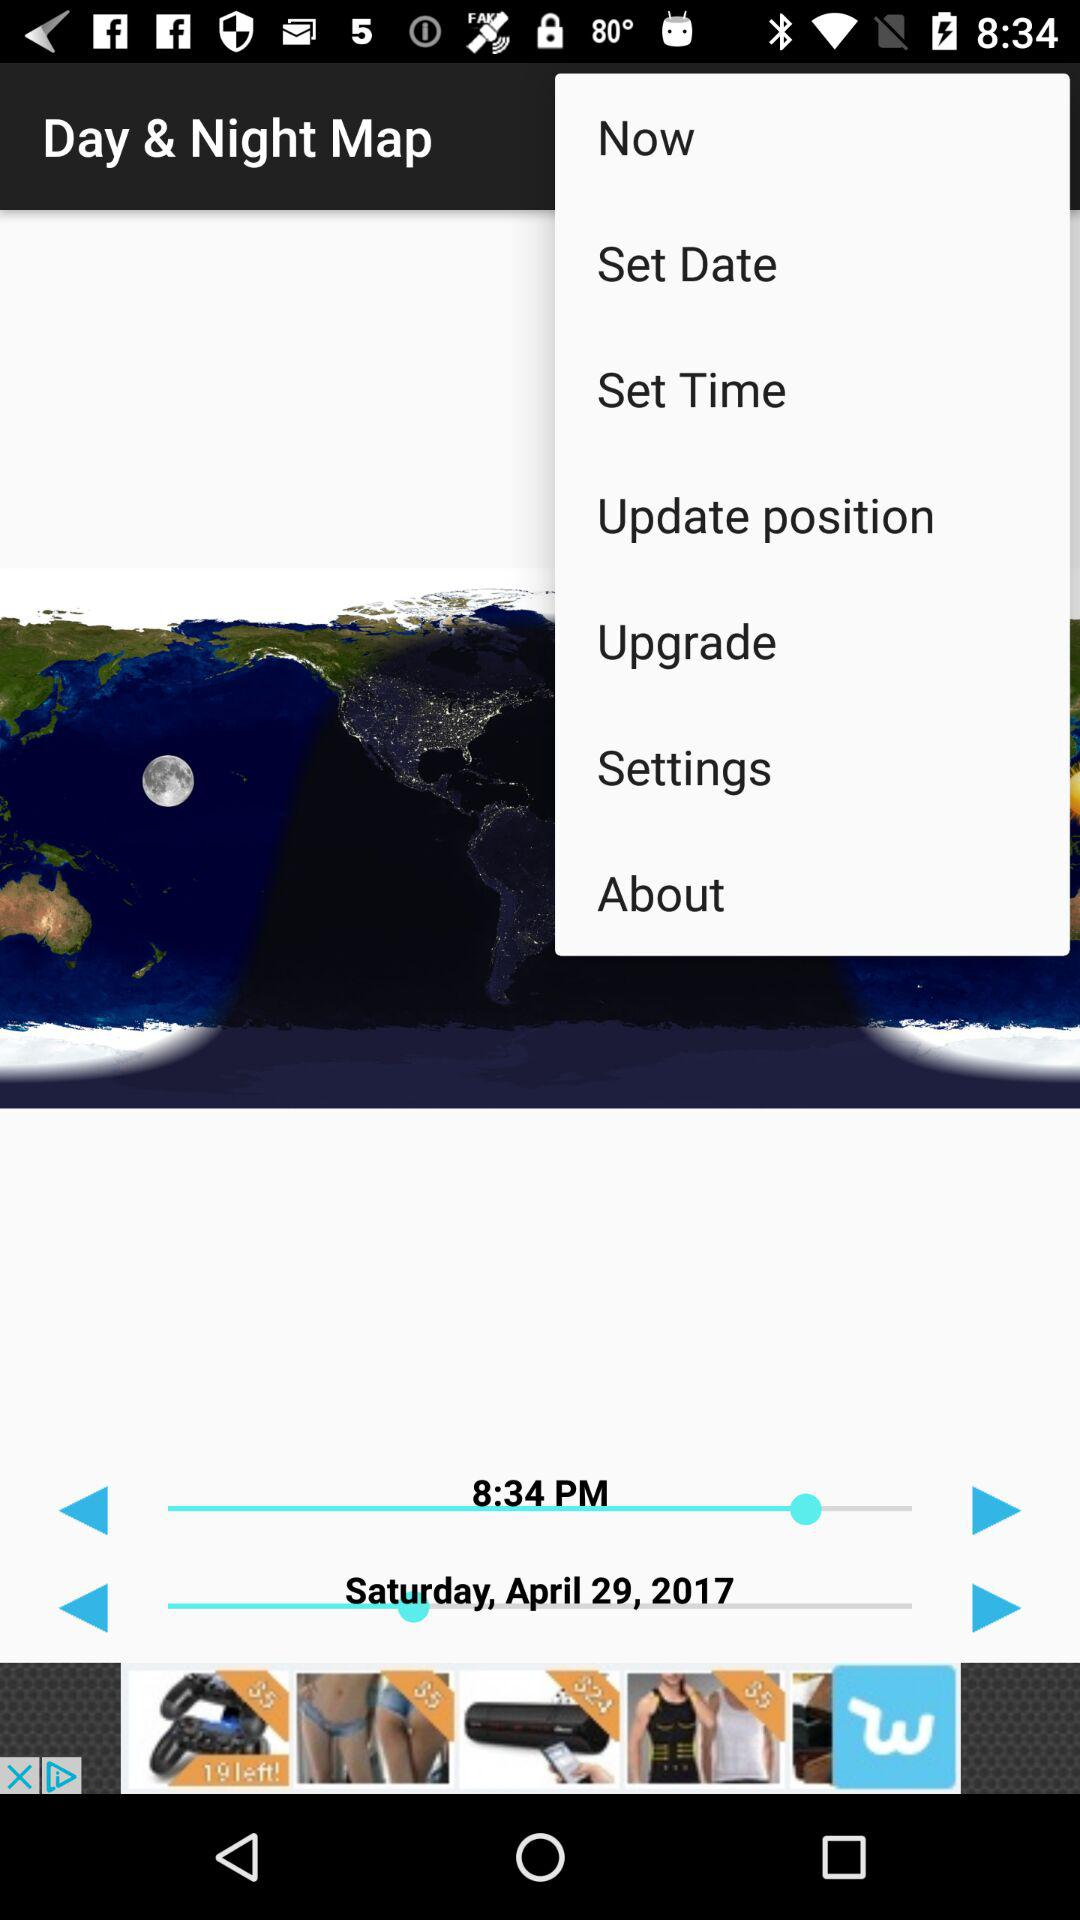What is the time shown on the screen? The time is 8:34 PM. 